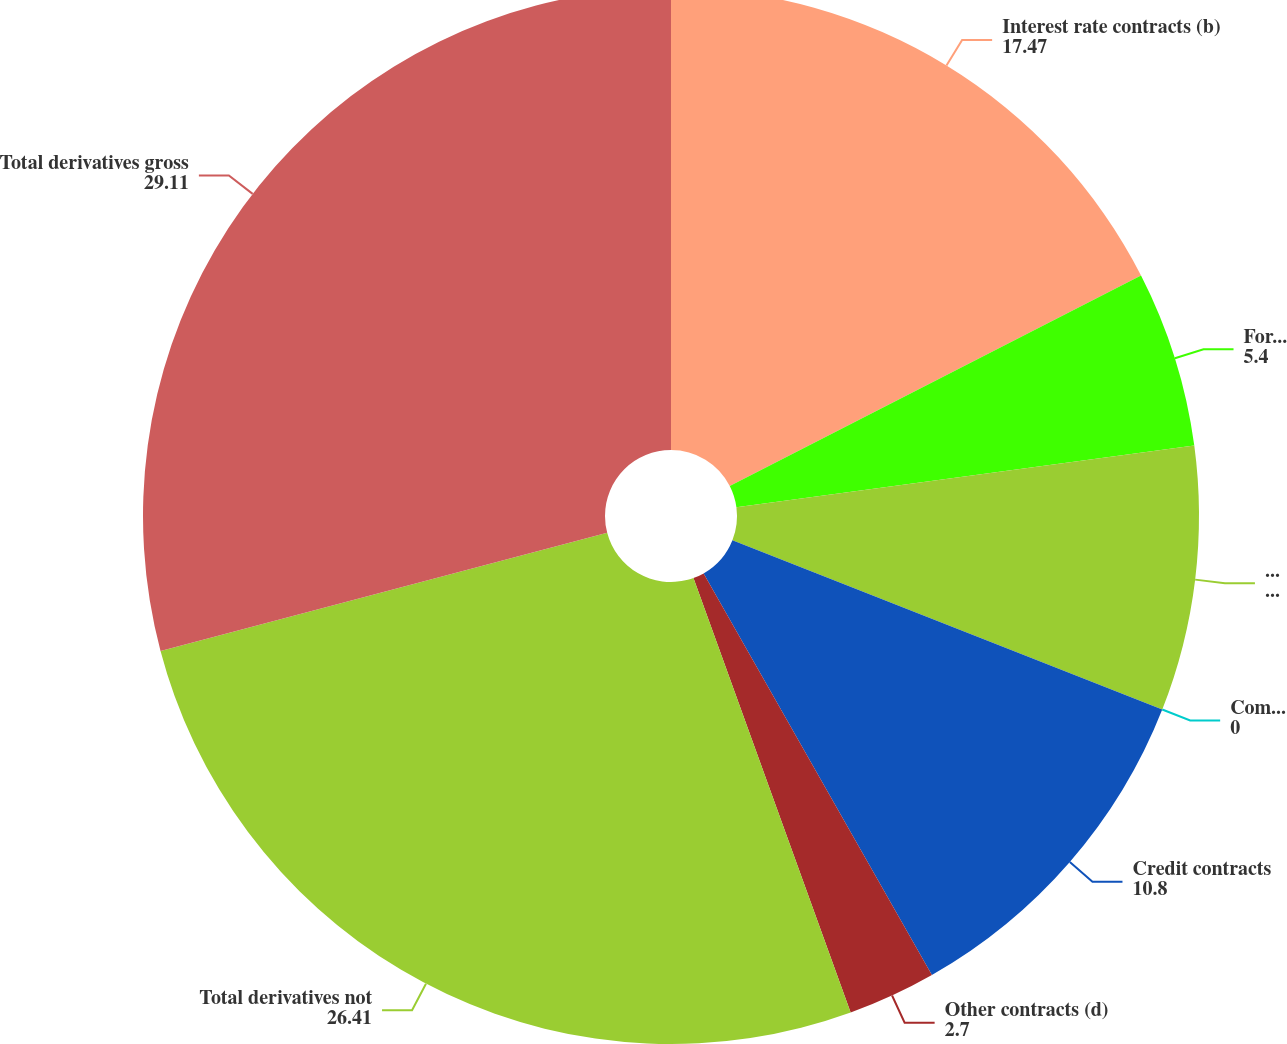Convert chart to OTSL. <chart><loc_0><loc_0><loc_500><loc_500><pie_chart><fcel>Interest rate contracts (b)<fcel>Foreign exchange contracts<fcel>Equity contracts (c)<fcel>Commodity contracts<fcel>Credit contracts<fcel>Other contracts (d)<fcel>Total derivatives not<fcel>Total derivatives gross<nl><fcel>17.47%<fcel>5.4%<fcel>8.1%<fcel>0.0%<fcel>10.8%<fcel>2.7%<fcel>26.41%<fcel>29.11%<nl></chart> 